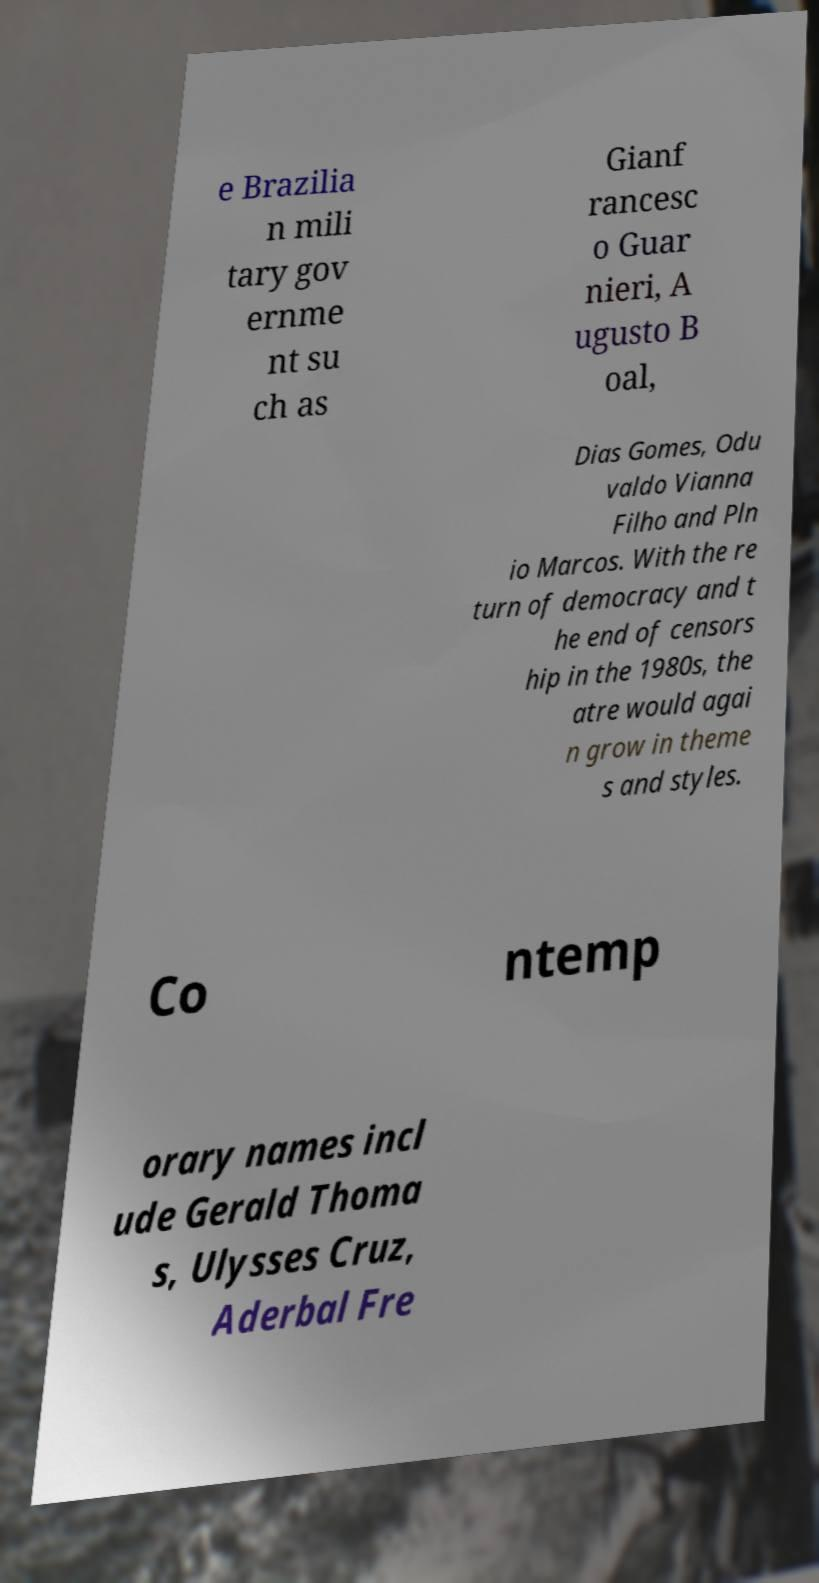There's text embedded in this image that I need extracted. Can you transcribe it verbatim? e Brazilia n mili tary gov ernme nt su ch as Gianf rancesc o Guar nieri, A ugusto B oal, Dias Gomes, Odu valdo Vianna Filho and Pln io Marcos. With the re turn of democracy and t he end of censors hip in the 1980s, the atre would agai n grow in theme s and styles. Co ntemp orary names incl ude Gerald Thoma s, Ulysses Cruz, Aderbal Fre 